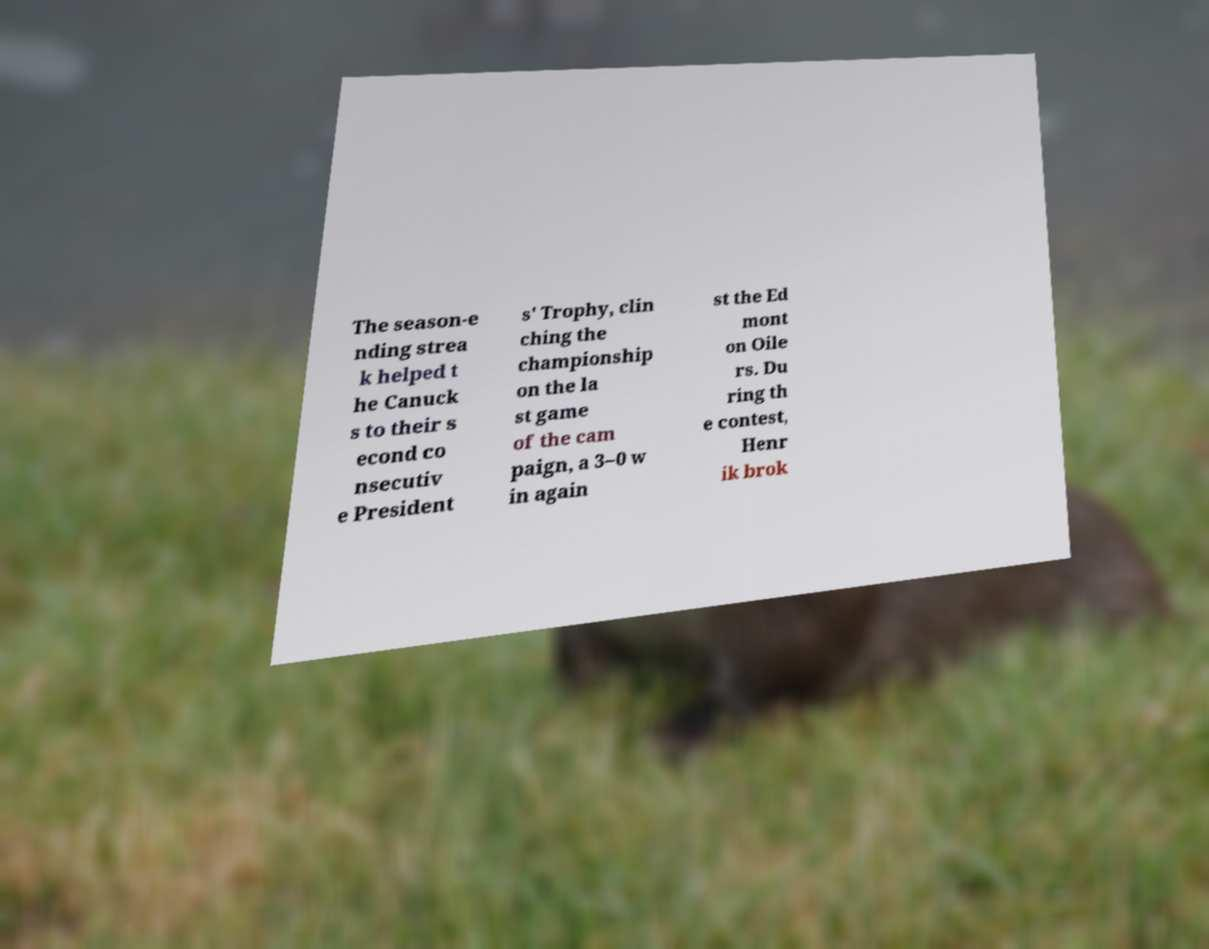I need the written content from this picture converted into text. Can you do that? The season-e nding strea k helped t he Canuck s to their s econd co nsecutiv e President s' Trophy, clin ching the championship on the la st game of the cam paign, a 3–0 w in again st the Ed mont on Oile rs. Du ring th e contest, Henr ik brok 